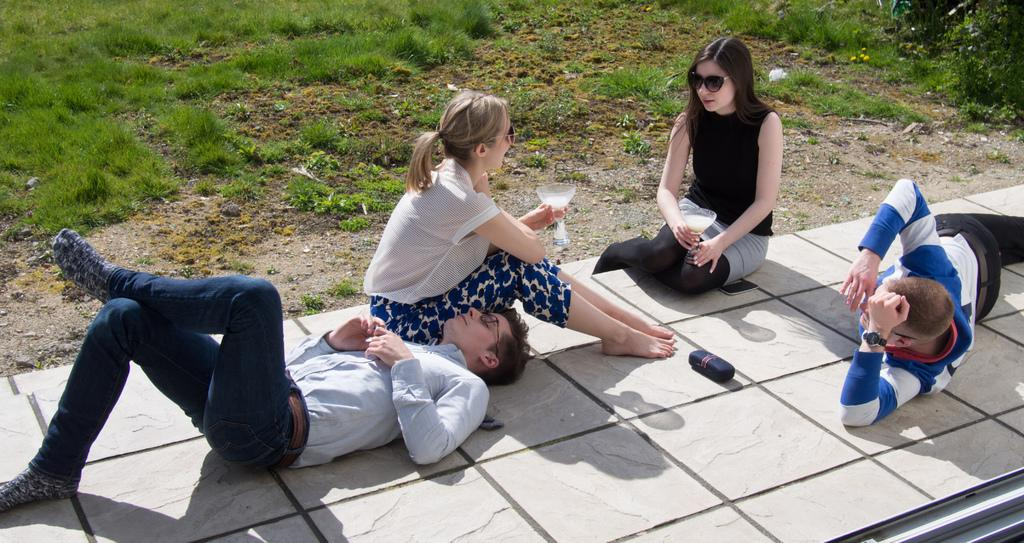How many people are present in the image? There are four people in the image. What are two of the people doing in the image? Two of the people are holding objects. What can be seen in the background of the image? There is grass visible in the background of the image. What type of book is being read by the person on the ship in the image? There is no ship or person reading a book present in the image. What acoustics can be heard in the image? There is no mention of sound or acoustics in the image, so it cannot be determined from the image. 